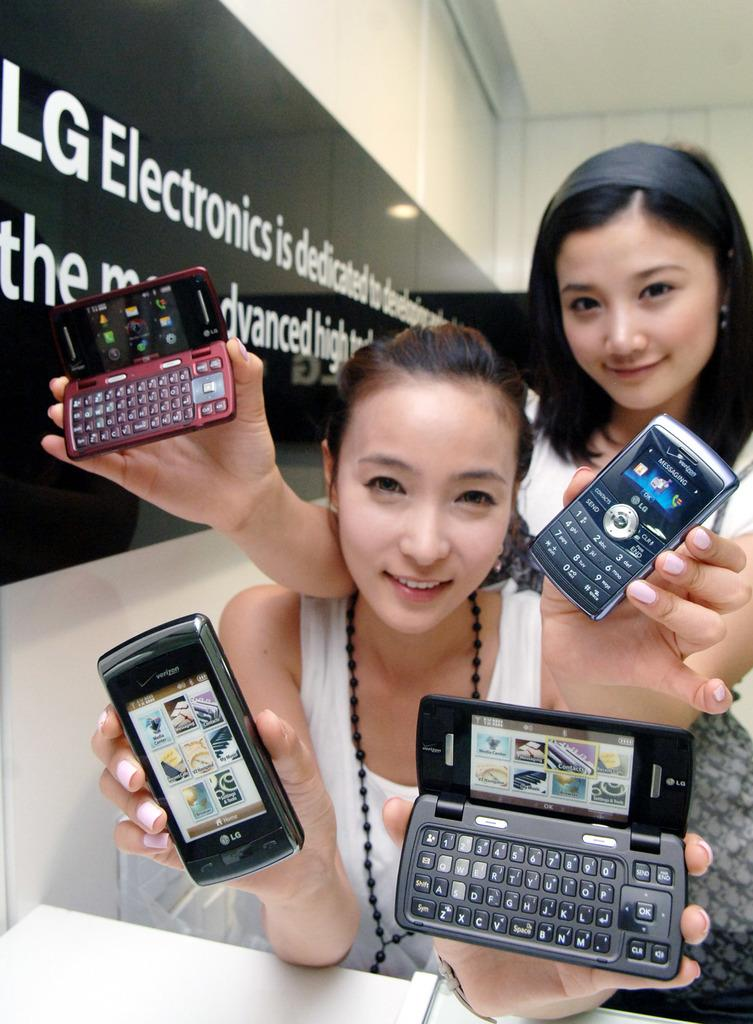<image>
Write a terse but informative summary of the picture. Two girls are holding up cellphones from LG Electronics. 